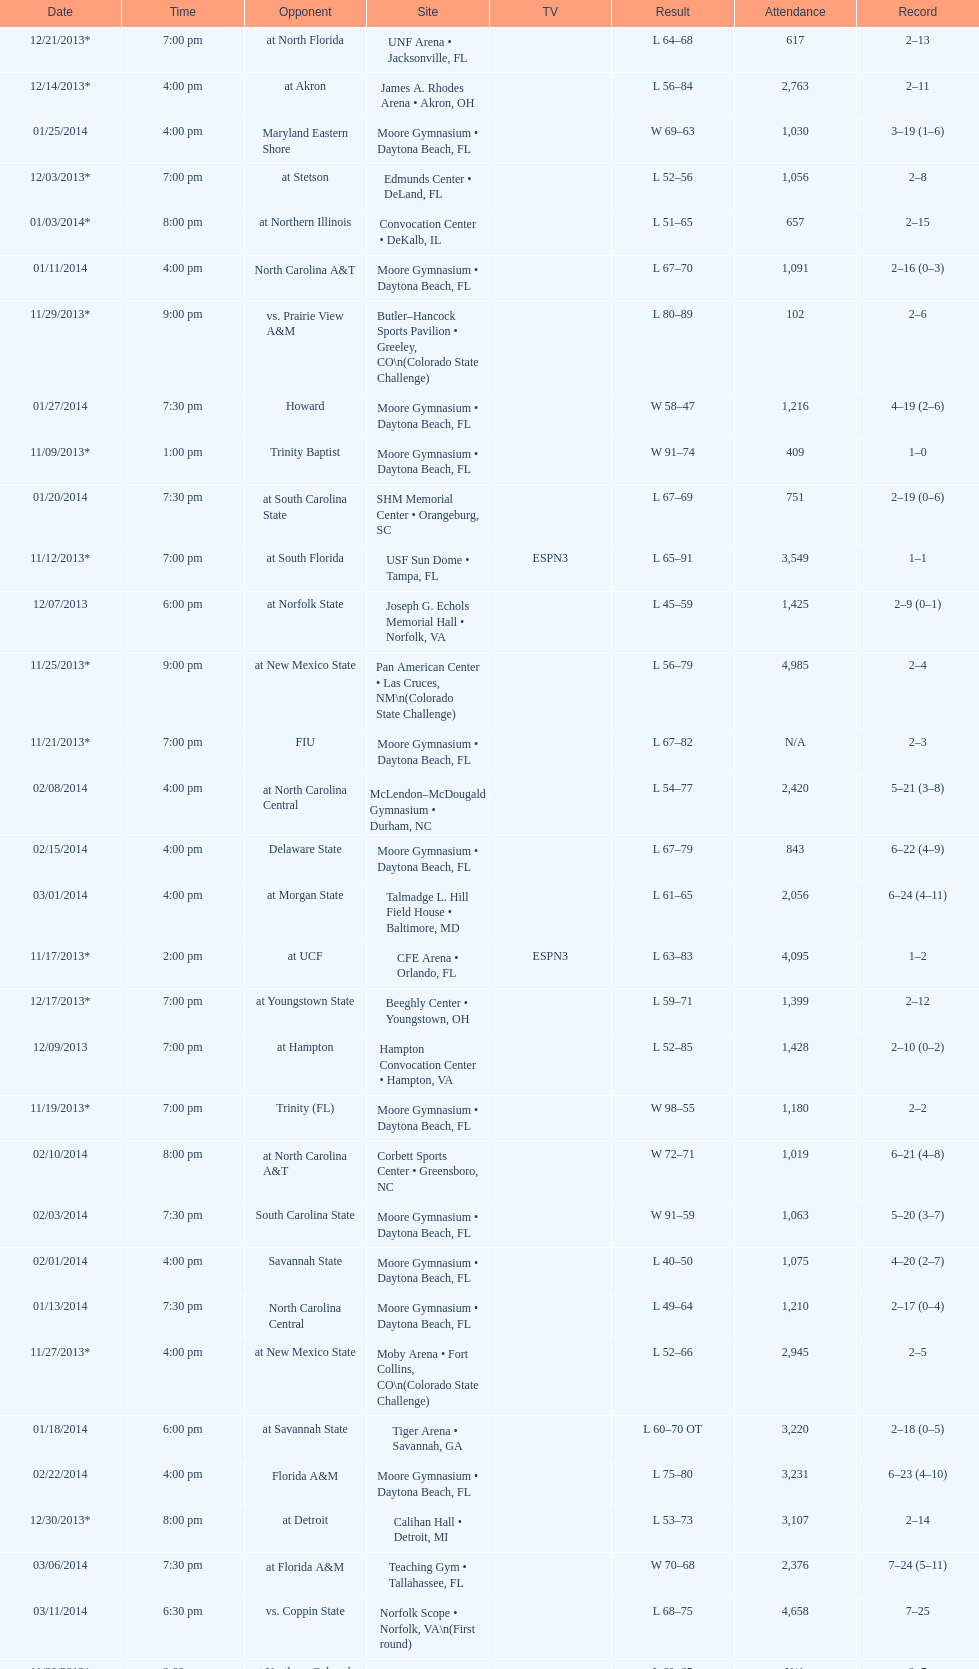How many teams had at most an attendance of 1,000? 6. 